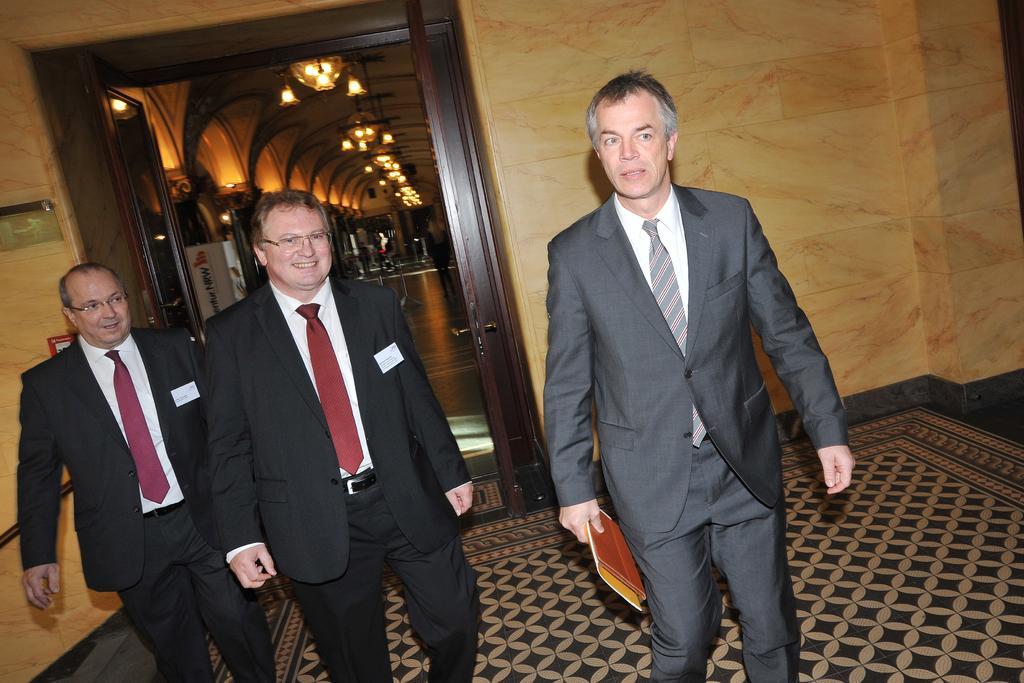Please provide a concise description of this image. In this image, we can see three people in a suits are walking. At the bottom, we can see a surface. Here a person is holding some objects. Left side of the image, we can see two people are smiling. Background we can see a wall, chandeliers, roof, banners, few people. 